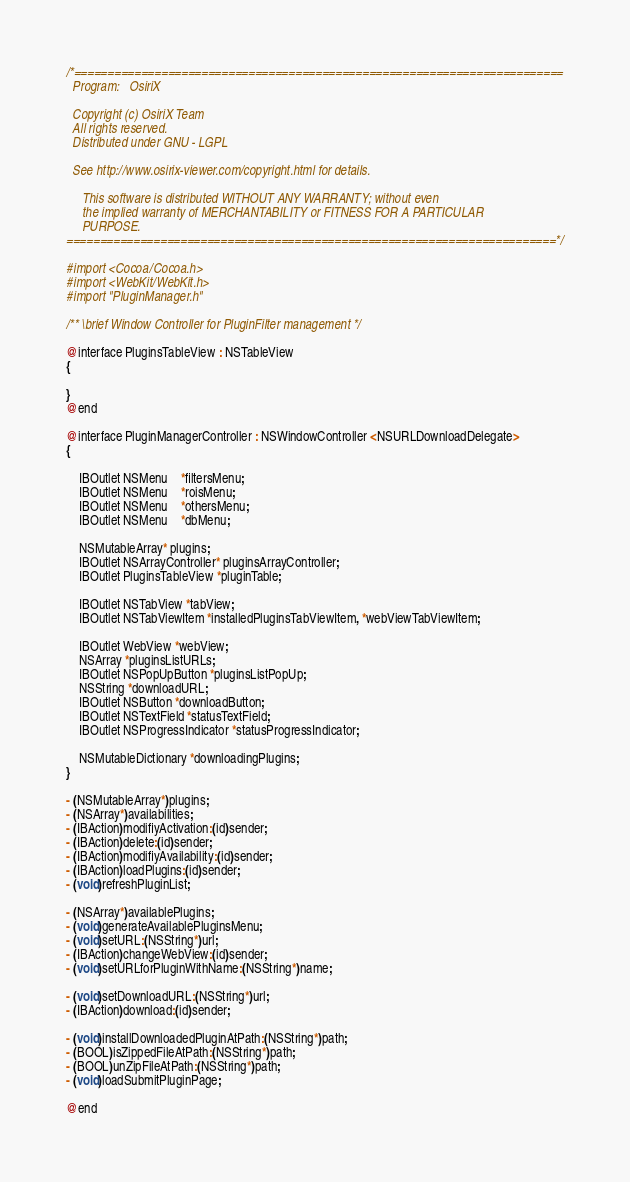Convert code to text. <code><loc_0><loc_0><loc_500><loc_500><_C_>/*=========================================================================
  Program:   OsiriX

  Copyright (c) OsiriX Team
  All rights reserved.
  Distributed under GNU - LGPL
  
  See http://www.osirix-viewer.com/copyright.html for details.

     This software is distributed WITHOUT ANY WARRANTY; without even
     the implied warranty of MERCHANTABILITY or FITNESS FOR A PARTICULAR
     PURPOSE.
=========================================================================*/

#import <Cocoa/Cocoa.h>
#import <WebKit/WebKit.h>
#import "PluginManager.h"

/** \brief Window Controller for PluginFilter management */

@interface PluginsTableView : NSTableView
{

}
@end

@interface PluginManagerController : NSWindowController <NSURLDownloadDelegate>
{

    IBOutlet NSMenu	*filtersMenu;
	IBOutlet NSMenu	*roisMenu;
	IBOutlet NSMenu	*othersMenu;
	IBOutlet NSMenu	*dbMenu;

	NSMutableArray* plugins;
	IBOutlet NSArrayController* pluginsArrayController;
	IBOutlet PluginsTableView *pluginTable;
	
	IBOutlet NSTabView *tabView;
	IBOutlet NSTabViewItem *installedPluginsTabViewItem, *webViewTabViewItem;
	
	IBOutlet WebView *webView;
	NSArray *pluginsListURLs;
	IBOutlet NSPopUpButton *pluginsListPopUp;
	NSString *downloadURL;
	IBOutlet NSButton *downloadButton;
	IBOutlet NSTextField *statusTextField;
	IBOutlet NSProgressIndicator *statusProgressIndicator;
    
    NSMutableDictionary *downloadingPlugins;
}

- (NSMutableArray*)plugins;
- (NSArray*)availabilities;
- (IBAction)modifiyActivation:(id)sender;
- (IBAction)delete:(id)sender;
- (IBAction)modifiyAvailability:(id)sender;
- (IBAction)loadPlugins:(id)sender;
- (void)refreshPluginList;

- (NSArray*)availablePlugins;
- (void)generateAvailablePluginsMenu;
- (void)setURL:(NSString*)url;
- (IBAction)changeWebView:(id)sender;
- (void)setURLforPluginWithName:(NSString*)name;

- (void)setDownloadURL:(NSString*)url;
- (IBAction)download:(id)sender;

- (void)installDownloadedPluginAtPath:(NSString*)path;
- (BOOL)isZippedFileAtPath:(NSString*)path;
- (BOOL)unZipFileAtPath:(NSString*)path;
- (void)loadSubmitPluginPage;

@end
</code> 